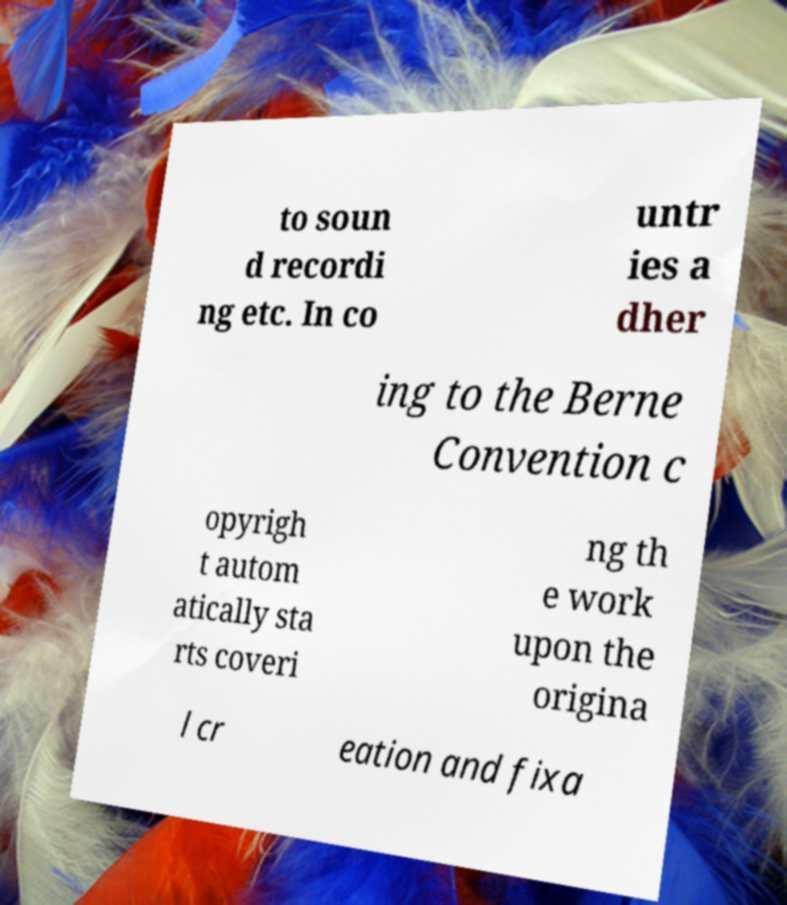Can you accurately transcribe the text from the provided image for me? to soun d recordi ng etc. In co untr ies a dher ing to the Berne Convention c opyrigh t autom atically sta rts coveri ng th e work upon the origina l cr eation and fixa 